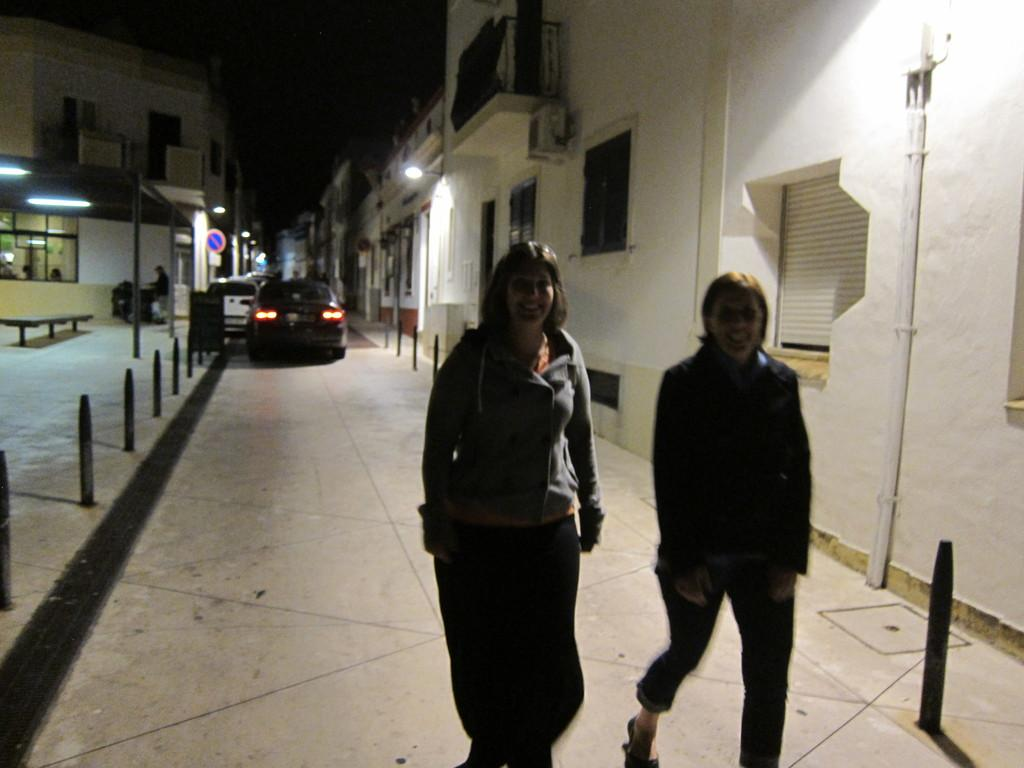What are the two people in the image doing? The two people in the image are walking on the road. What type of objects can be seen along the road? Metal poles are present in the image. What else can be seen on the road? Vehicles are visible in the image. What structures are visible in the background? There are buildings in the image. What type of illumination is present in the image? Lights are present in the image. What type of seating is visible in the image? A bench is visible in the image. What type of information is displayed in the image? A sign board is present in the image. How would you describe the overall lighting in the image? The background of the image appears dark. How does the person in the image attack the building with their eyes? There is no person attacking a building with their eyes in the image. 